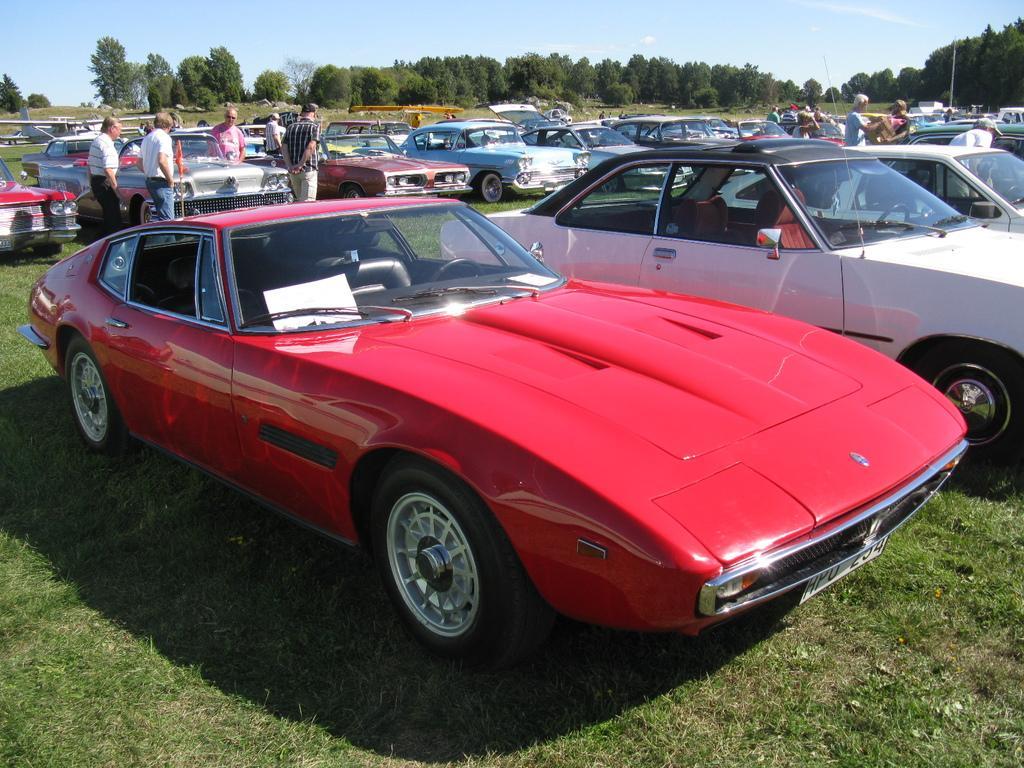Describe this image in one or two sentences. In this image there are vehicles, persons and trees and there is grass on the ground. 